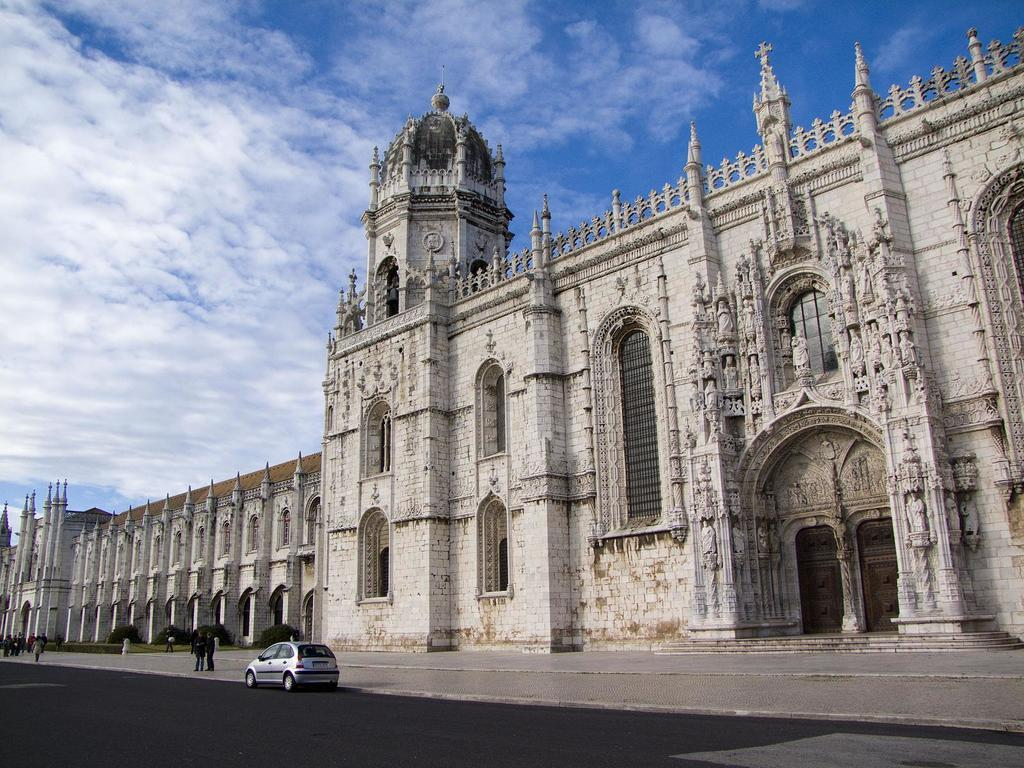What type of structures can be seen in the image? There are buildings in the image. What else is present in the image besides the buildings? There is a road in the image, and a car is on the road. Are there any people visible in the image? Yes, there are people visible in the image. What can be seen in the background of the image? The sky is visible in the background of the image. What type of mint is growing on the side of the road in the image? There is no mint visible in the image; it features buildings, a road, a car, people, and the sky. How many bits of information can be gathered from the image? It is not possible to quantify the amount of information that can be gathered from the image in terms of "bits." 